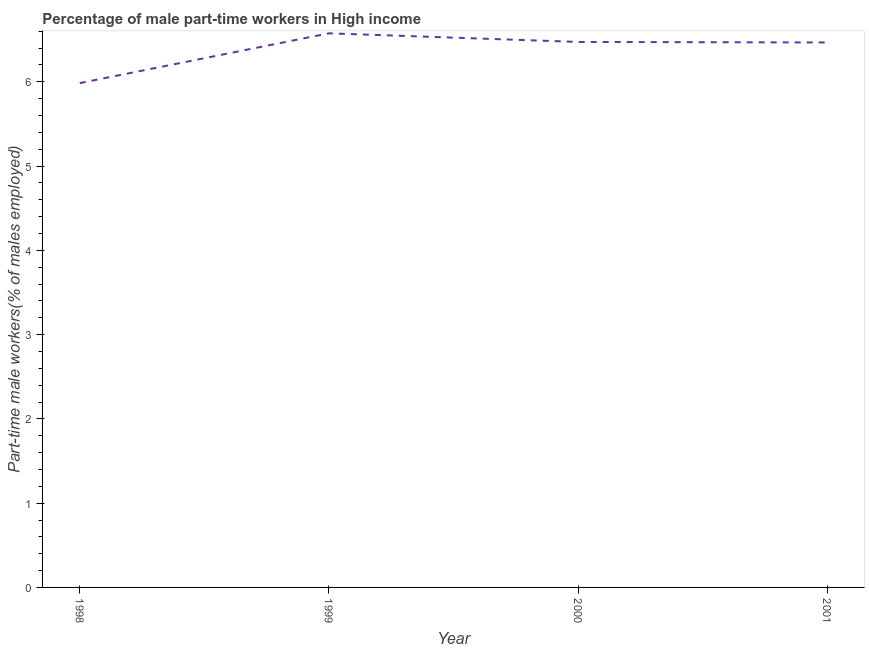What is the percentage of part-time male workers in 2000?
Make the answer very short. 6.47. Across all years, what is the maximum percentage of part-time male workers?
Your answer should be very brief. 6.58. Across all years, what is the minimum percentage of part-time male workers?
Make the answer very short. 5.98. What is the sum of the percentage of part-time male workers?
Keep it short and to the point. 25.5. What is the difference between the percentage of part-time male workers in 1999 and 2001?
Offer a very short reply. 0.11. What is the average percentage of part-time male workers per year?
Your answer should be very brief. 6.38. What is the median percentage of part-time male workers?
Offer a very short reply. 6.47. In how many years, is the percentage of part-time male workers greater than 0.4 %?
Your answer should be compact. 4. Do a majority of the years between 2001 and 2000 (inclusive) have percentage of part-time male workers greater than 5.8 %?
Ensure brevity in your answer.  No. What is the ratio of the percentage of part-time male workers in 2000 to that in 2001?
Provide a short and direct response. 1. Is the difference between the percentage of part-time male workers in 1999 and 2001 greater than the difference between any two years?
Give a very brief answer. No. What is the difference between the highest and the second highest percentage of part-time male workers?
Your response must be concise. 0.1. Is the sum of the percentage of part-time male workers in 1999 and 2000 greater than the maximum percentage of part-time male workers across all years?
Provide a succinct answer. Yes. What is the difference between the highest and the lowest percentage of part-time male workers?
Your answer should be compact. 0.59. Does the percentage of part-time male workers monotonically increase over the years?
Provide a succinct answer. No. How many lines are there?
Your answer should be very brief. 1. How many years are there in the graph?
Your answer should be compact. 4. What is the difference between two consecutive major ticks on the Y-axis?
Offer a terse response. 1. Are the values on the major ticks of Y-axis written in scientific E-notation?
Offer a very short reply. No. What is the title of the graph?
Keep it short and to the point. Percentage of male part-time workers in High income. What is the label or title of the Y-axis?
Make the answer very short. Part-time male workers(% of males employed). What is the Part-time male workers(% of males employed) of 1998?
Offer a very short reply. 5.98. What is the Part-time male workers(% of males employed) in 1999?
Offer a very short reply. 6.58. What is the Part-time male workers(% of males employed) in 2000?
Make the answer very short. 6.47. What is the Part-time male workers(% of males employed) in 2001?
Provide a succinct answer. 6.47. What is the difference between the Part-time male workers(% of males employed) in 1998 and 1999?
Offer a very short reply. -0.59. What is the difference between the Part-time male workers(% of males employed) in 1998 and 2000?
Offer a terse response. -0.49. What is the difference between the Part-time male workers(% of males employed) in 1998 and 2001?
Ensure brevity in your answer.  -0.48. What is the difference between the Part-time male workers(% of males employed) in 1999 and 2000?
Your answer should be compact. 0.1. What is the difference between the Part-time male workers(% of males employed) in 1999 and 2001?
Provide a succinct answer. 0.11. What is the difference between the Part-time male workers(% of males employed) in 2000 and 2001?
Provide a succinct answer. 0.01. What is the ratio of the Part-time male workers(% of males employed) in 1998 to that in 1999?
Provide a succinct answer. 0.91. What is the ratio of the Part-time male workers(% of males employed) in 1998 to that in 2000?
Offer a very short reply. 0.93. What is the ratio of the Part-time male workers(% of males employed) in 1998 to that in 2001?
Provide a succinct answer. 0.93. What is the ratio of the Part-time male workers(% of males employed) in 1999 to that in 2001?
Give a very brief answer. 1.02. 